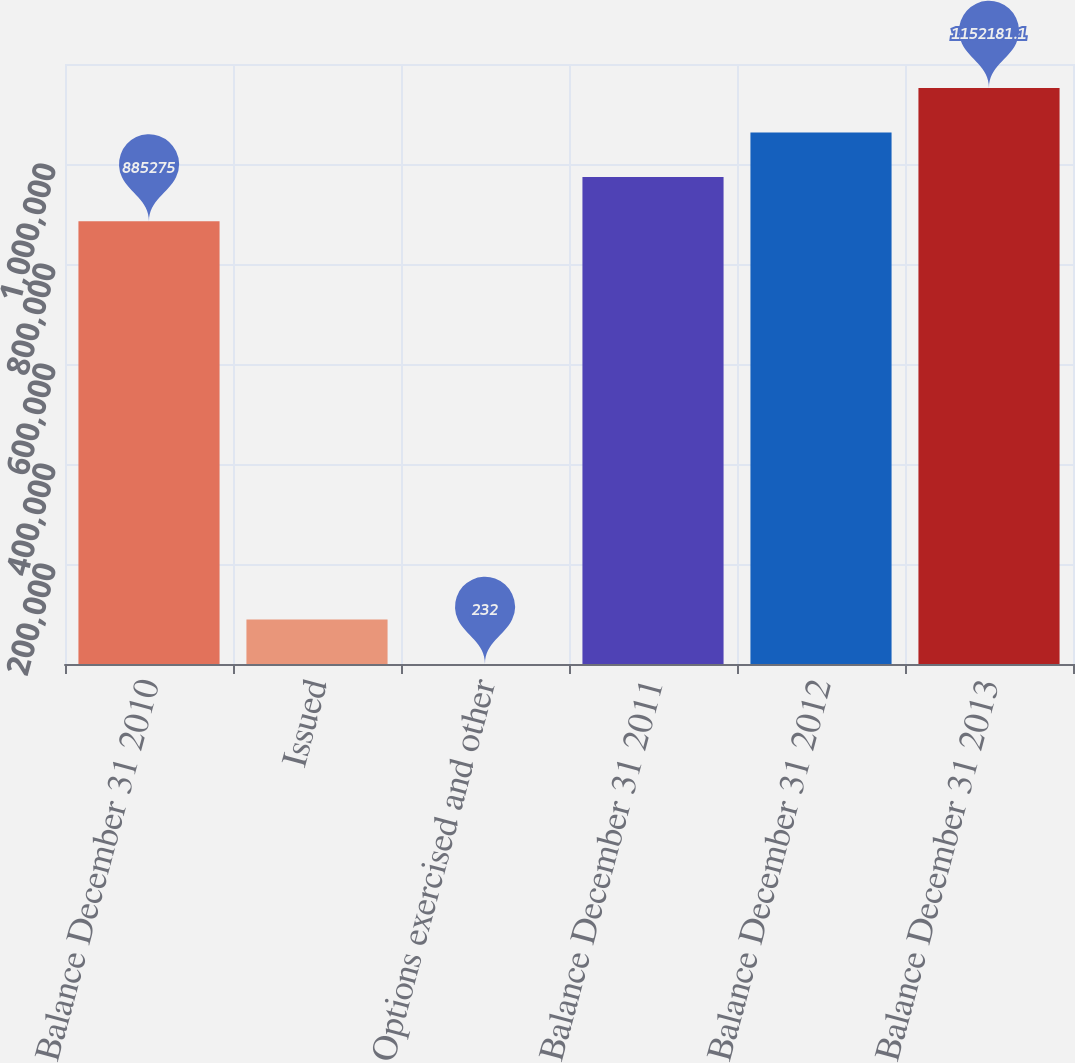Convert chart to OTSL. <chart><loc_0><loc_0><loc_500><loc_500><bar_chart><fcel>Balance December 31 2010<fcel>Issued<fcel>Options exercised and other<fcel>Balance December 31 2011<fcel>Balance December 31 2012<fcel>Balance December 31 2013<nl><fcel>885275<fcel>89200.7<fcel>232<fcel>974244<fcel>1.06321e+06<fcel>1.15218e+06<nl></chart> 